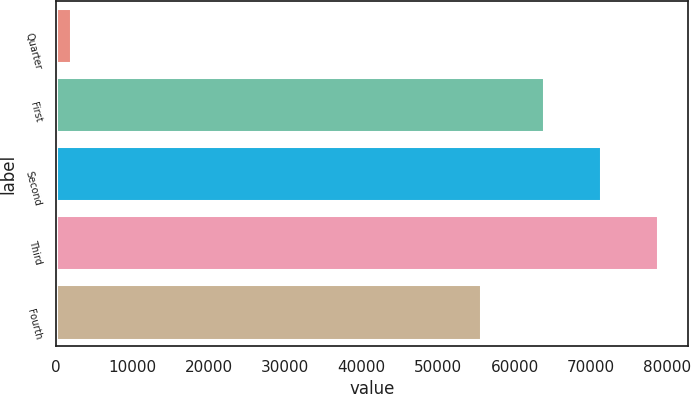Convert chart to OTSL. <chart><loc_0><loc_0><loc_500><loc_500><bar_chart><fcel>Quarter<fcel>First<fcel>Second<fcel>Third<fcel>Fourth<nl><fcel>2010<fcel>63789<fcel>71291.8<fcel>78794.6<fcel>55578<nl></chart> 